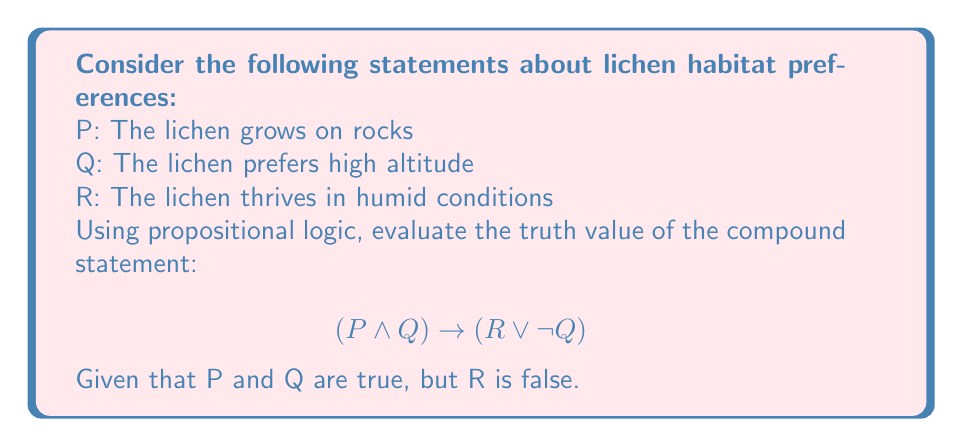What is the answer to this math problem? Let's approach this step-by-step:

1) First, we need to determine the truth values of the individual propositions:
   P: True
   Q: True
   R: False

2) Now, let's evaluate the left side of the implication: $(P \land Q)$
   $True \land True = True$

3) Next, let's evaluate the right side of the implication: $(R \lor \neg Q)$
   $R$ is False, so we need to evaluate $\neg Q$
   $\neg Q = \neg True = False$
   Now we have: $False \lor False = False$

4) So our implication has become:
   $True \rightarrow False$

5) Recall the truth table for implication:
   $$\begin{array}{|c|c|c|}
   \hline
   P & Q & P \rightarrow Q \\
   \hline
   T & T & T \\
   T & F & F \\
   F & T & T \\
   F & F & T \\
   \hline
   \end{array}$$

6) We can see that when the antecedent (left side) is True and the consequent (right side) is False, the implication is False.

Therefore, the compound statement is False.
Answer: False 